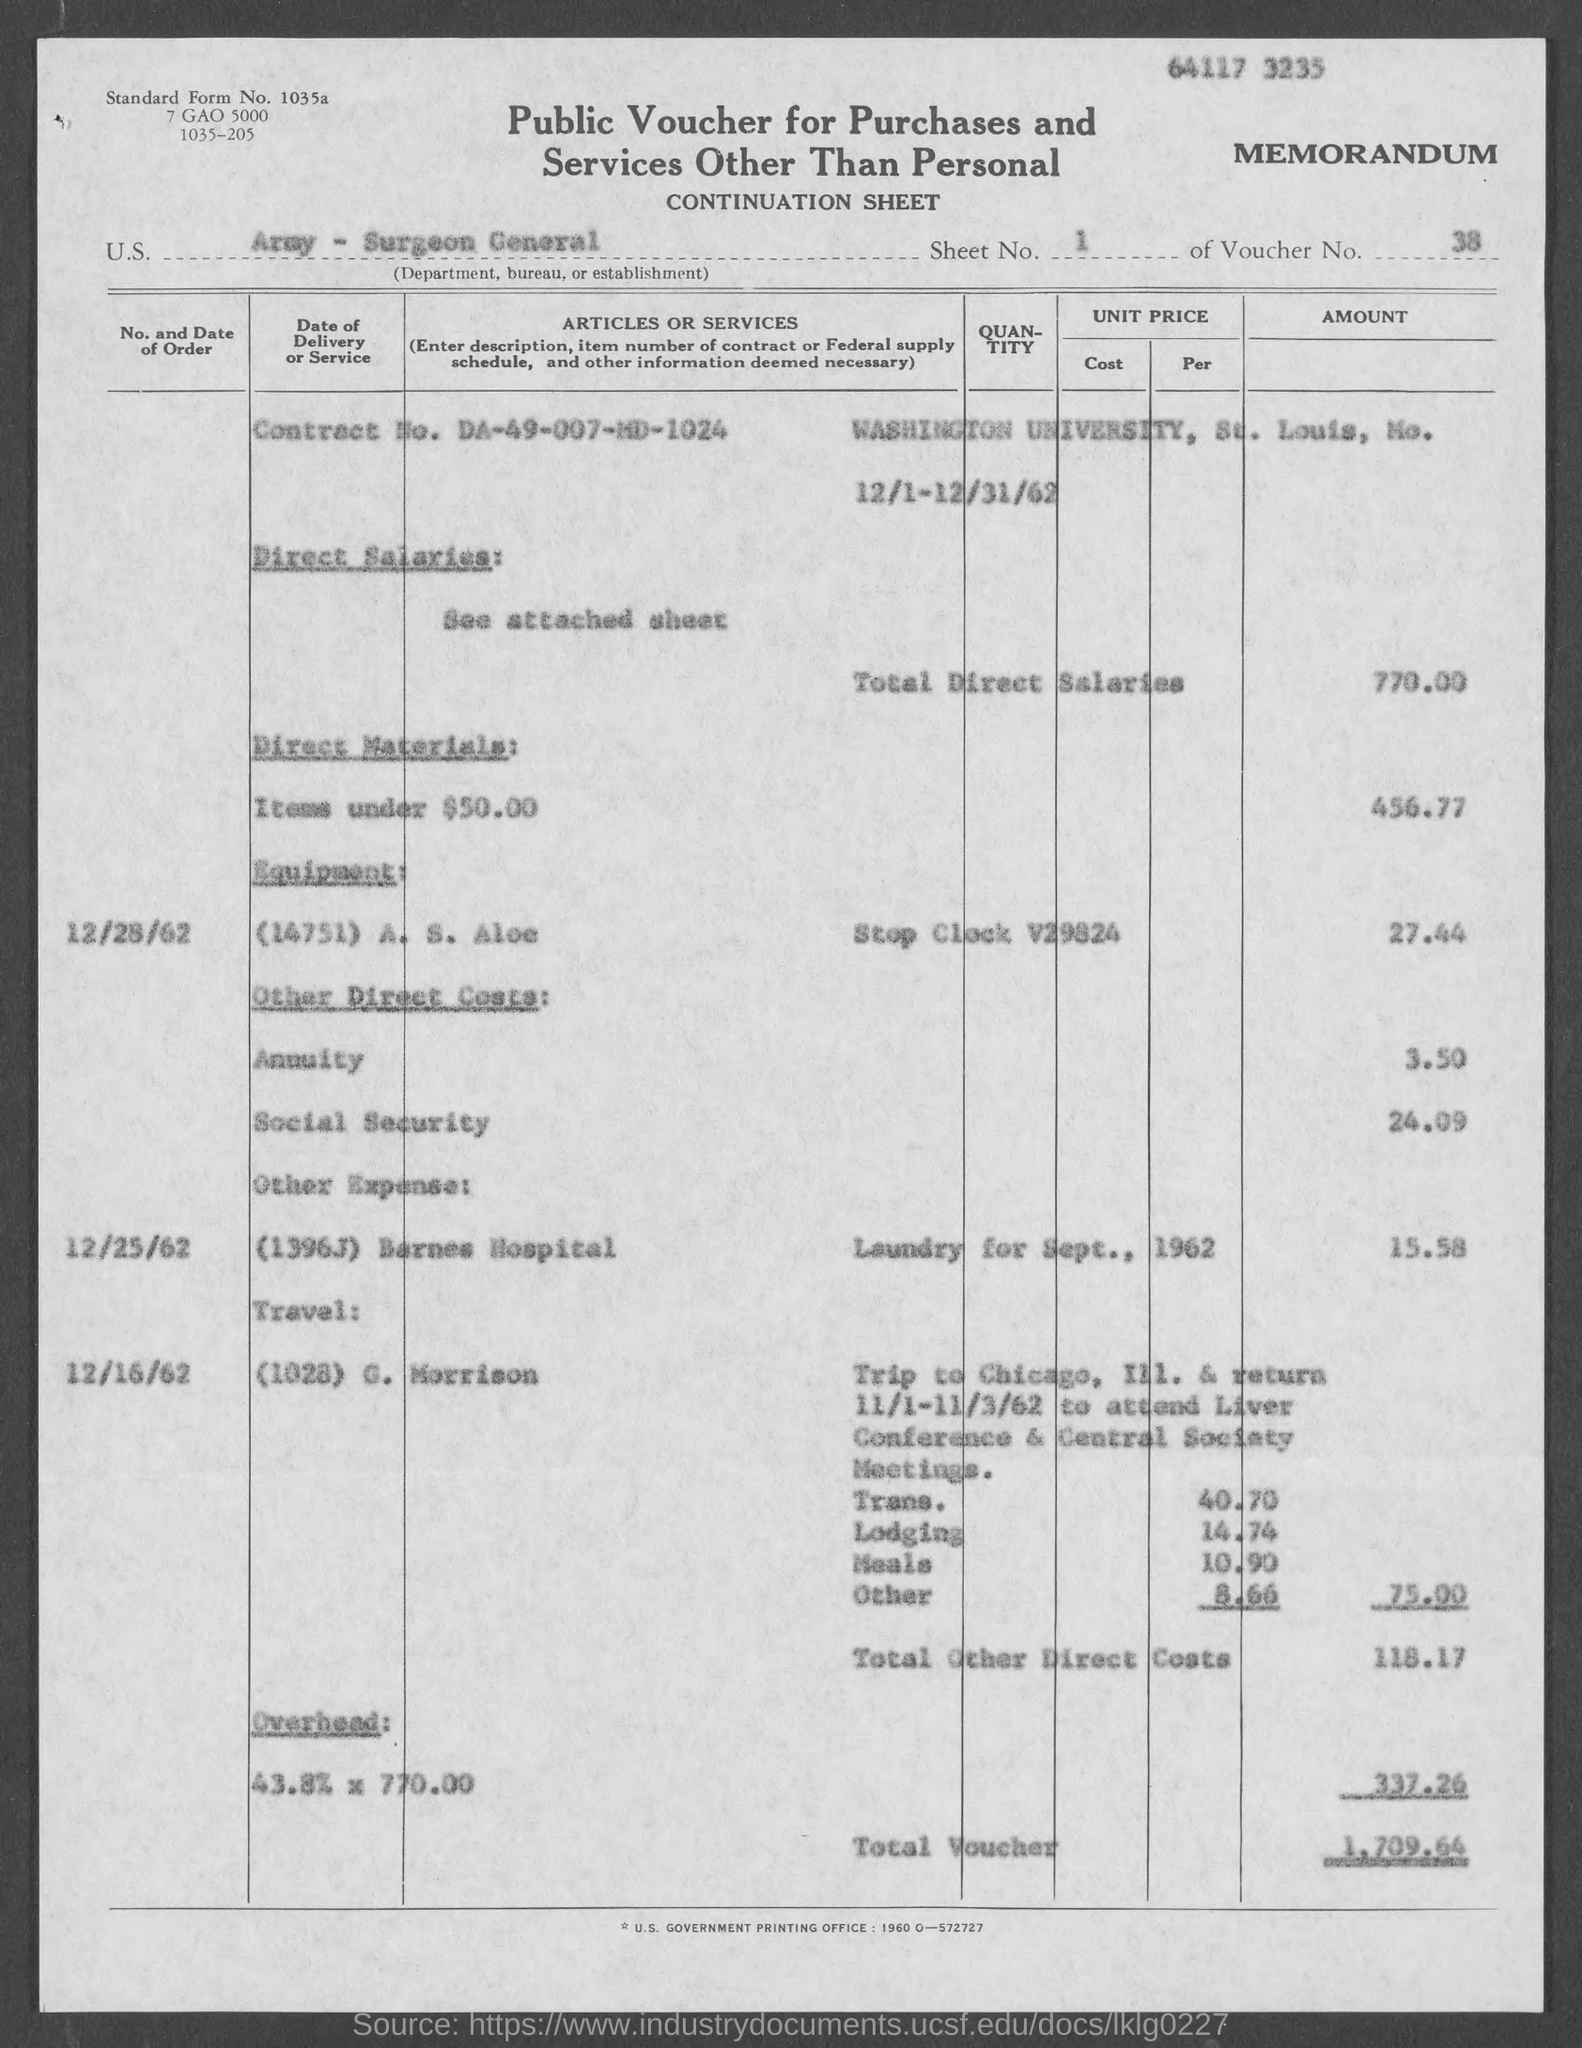Which department is mentioned?
Your answer should be compact. Army - Surgeon General. What is the sheet no.?
Your answer should be very brief. 1. What is the voucher number?
Your answer should be very brief. 38. What is the total voucher?
Provide a succinct answer. 1,709.64. 